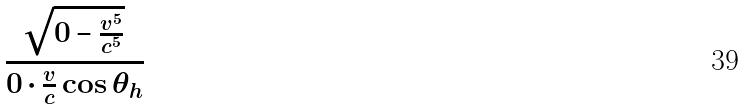<formula> <loc_0><loc_0><loc_500><loc_500>\frac { \sqrt { 0 - \frac { v ^ { 5 } } { c ^ { 5 } } } } { 0 \cdot \frac { v } { c } \cos \theta _ { h } }</formula> 